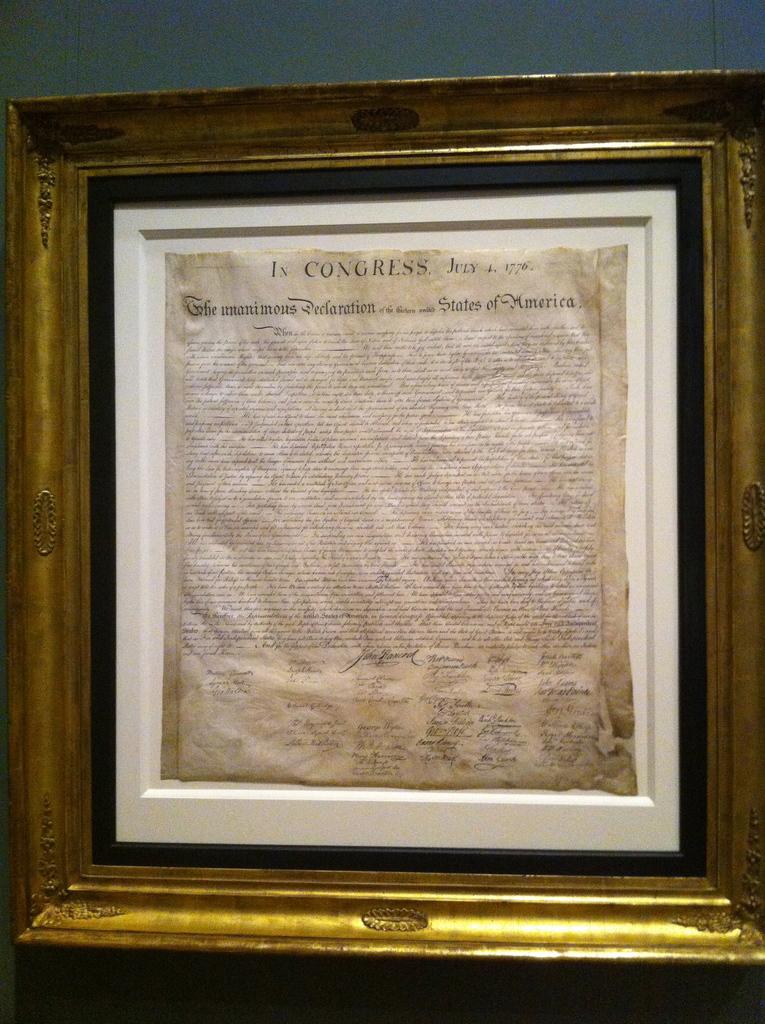What year was this written?
Offer a terse response. 1776. What is this famous document?
Ensure brevity in your answer.  Declaration of independence . 